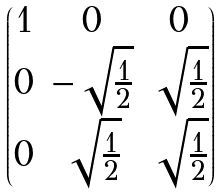<formula> <loc_0><loc_0><loc_500><loc_500>\begin{pmatrix} 1 & 0 & 0 \\ 0 & - \sqrt { \frac { 1 } { 2 } } & \sqrt { \frac { 1 } { 2 } } \\ 0 & \sqrt { \frac { 1 } { 2 } } & \sqrt { \frac { 1 } { 2 } } \end{pmatrix}</formula> 